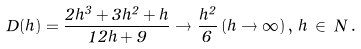<formula> <loc_0><loc_0><loc_500><loc_500>D ( h ) = \frac { 2 h ^ { 3 } + 3 h ^ { 2 } + h } { 1 2 h + 9 } \to \frac { h ^ { 2 } } { 6 } \, ( h \to \infty ) \, , \, h \, \in \, N \, .</formula> 